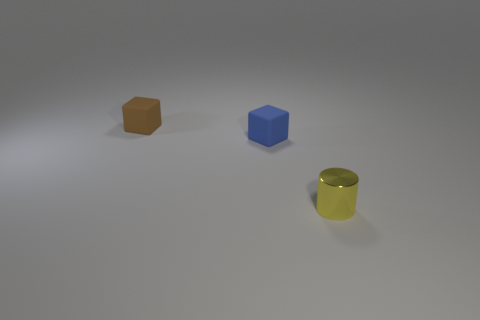Add 1 small cubes. How many objects exist? 4 Subtract all cylinders. How many objects are left? 2 Add 3 small yellow metal objects. How many small yellow metal objects exist? 4 Subtract 0 purple cylinders. How many objects are left? 3 Subtract all tiny gray shiny things. Subtract all tiny shiny cylinders. How many objects are left? 2 Add 3 yellow metal cylinders. How many yellow metal cylinders are left? 4 